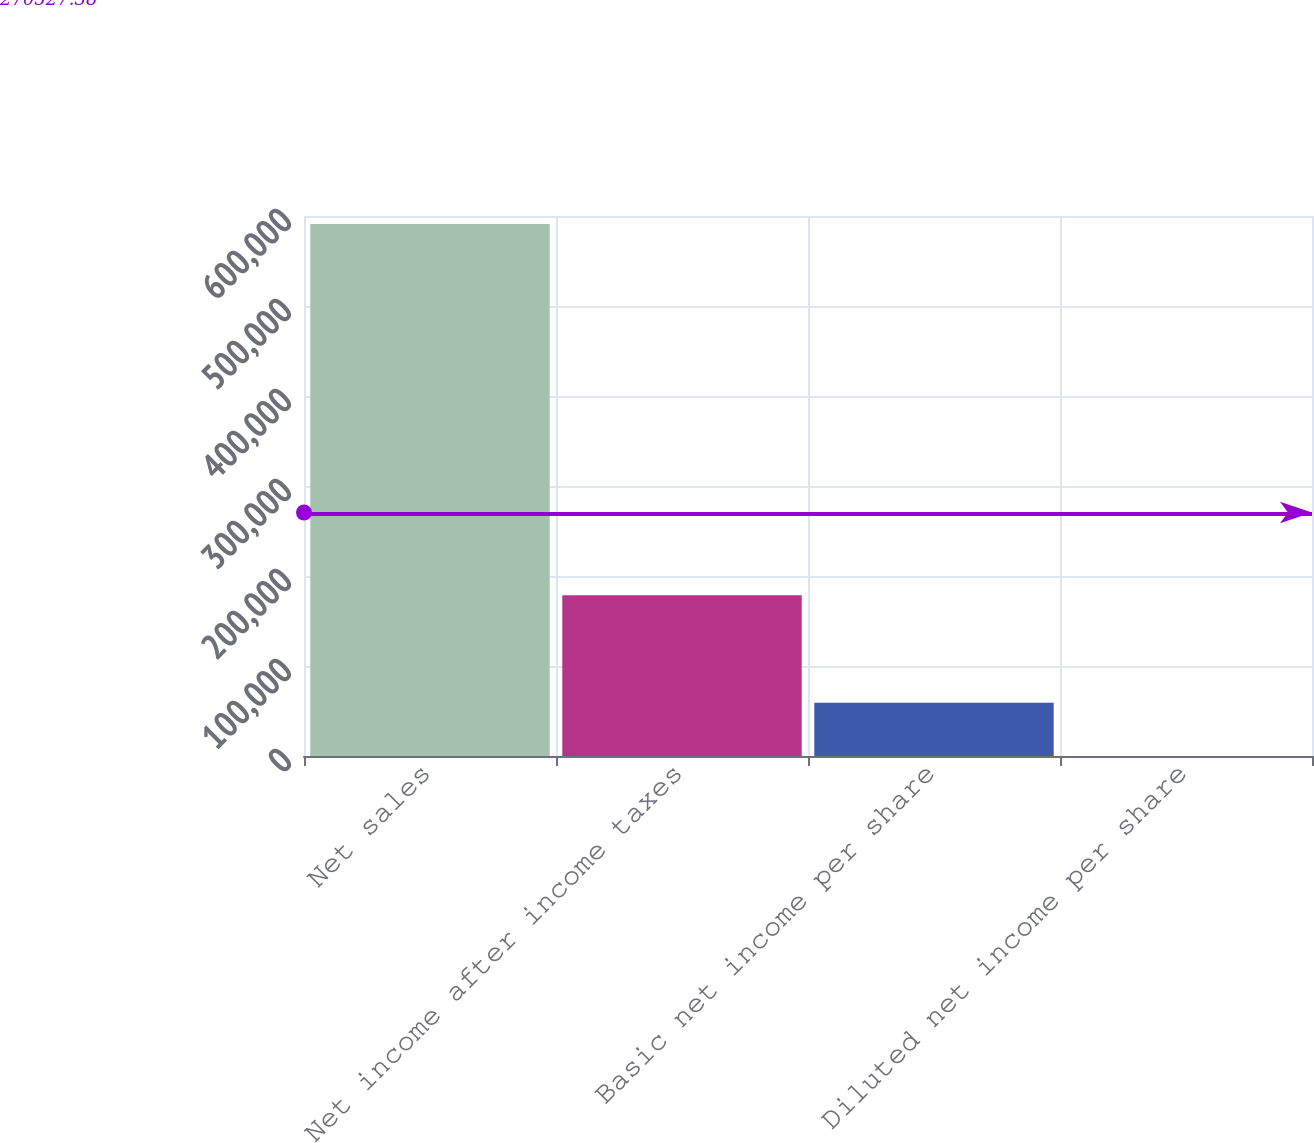Convert chart. <chart><loc_0><loc_0><loc_500><loc_500><bar_chart><fcel>Net sales<fcel>Net income after income taxes<fcel>Basic net income per share<fcel>Diluted net income per share<nl><fcel>591050<fcel>178524<fcel>59106.5<fcel>1.64<nl></chart> 